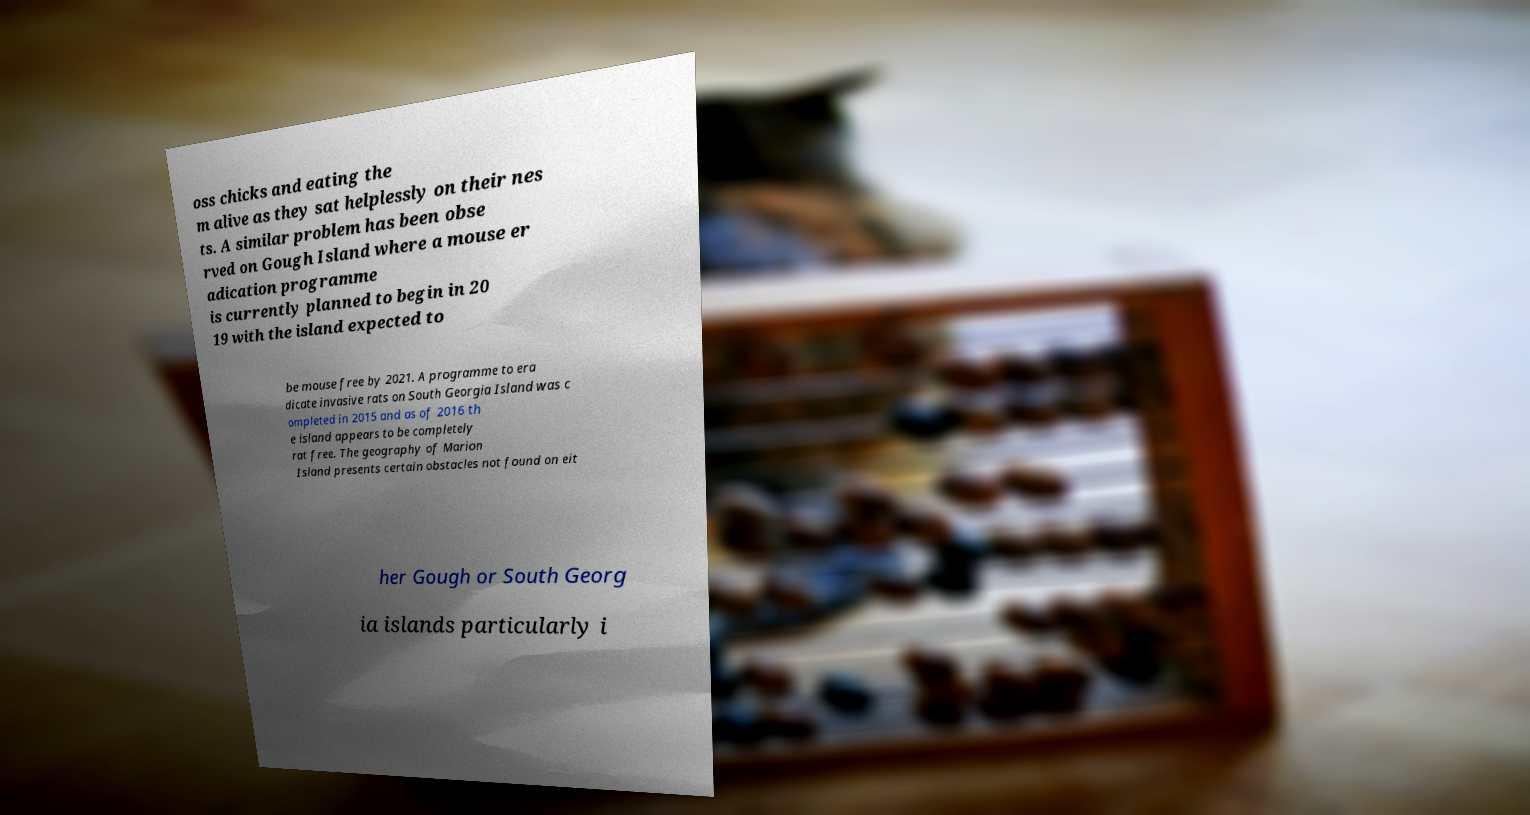Can you read and provide the text displayed in the image?This photo seems to have some interesting text. Can you extract and type it out for me? oss chicks and eating the m alive as they sat helplessly on their nes ts. A similar problem has been obse rved on Gough Island where a mouse er adication programme is currently planned to begin in 20 19 with the island expected to be mouse free by 2021. A programme to era dicate invasive rats on South Georgia Island was c ompleted in 2015 and as of 2016 th e island appears to be completely rat free. The geography of Marion Island presents certain obstacles not found on eit her Gough or South Georg ia islands particularly i 